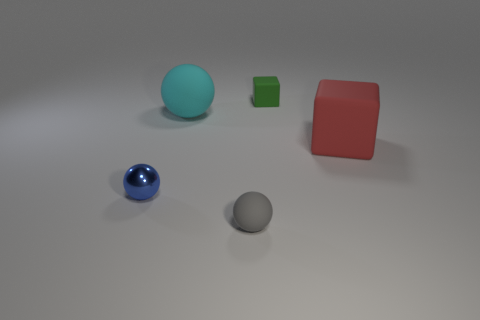Add 4 small matte cubes. How many objects exist? 9 Subtract all spheres. How many objects are left? 2 Add 1 shiny objects. How many shiny objects are left? 2 Add 2 large green shiny objects. How many large green shiny objects exist? 2 Subtract 0 green cylinders. How many objects are left? 5 Subtract all tiny shiny things. Subtract all big red blocks. How many objects are left? 3 